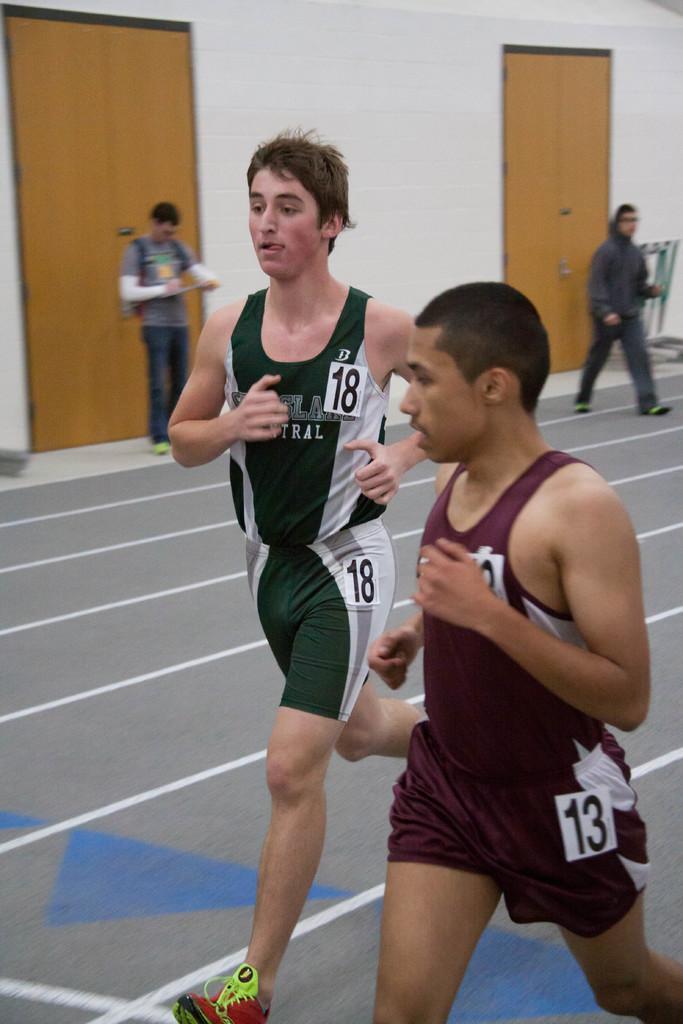In one or two sentences, can you explain what this image depicts? In the image two persons are running. Behind them two persons are walking. Behind them there is wall, on the wall there are two doors. 